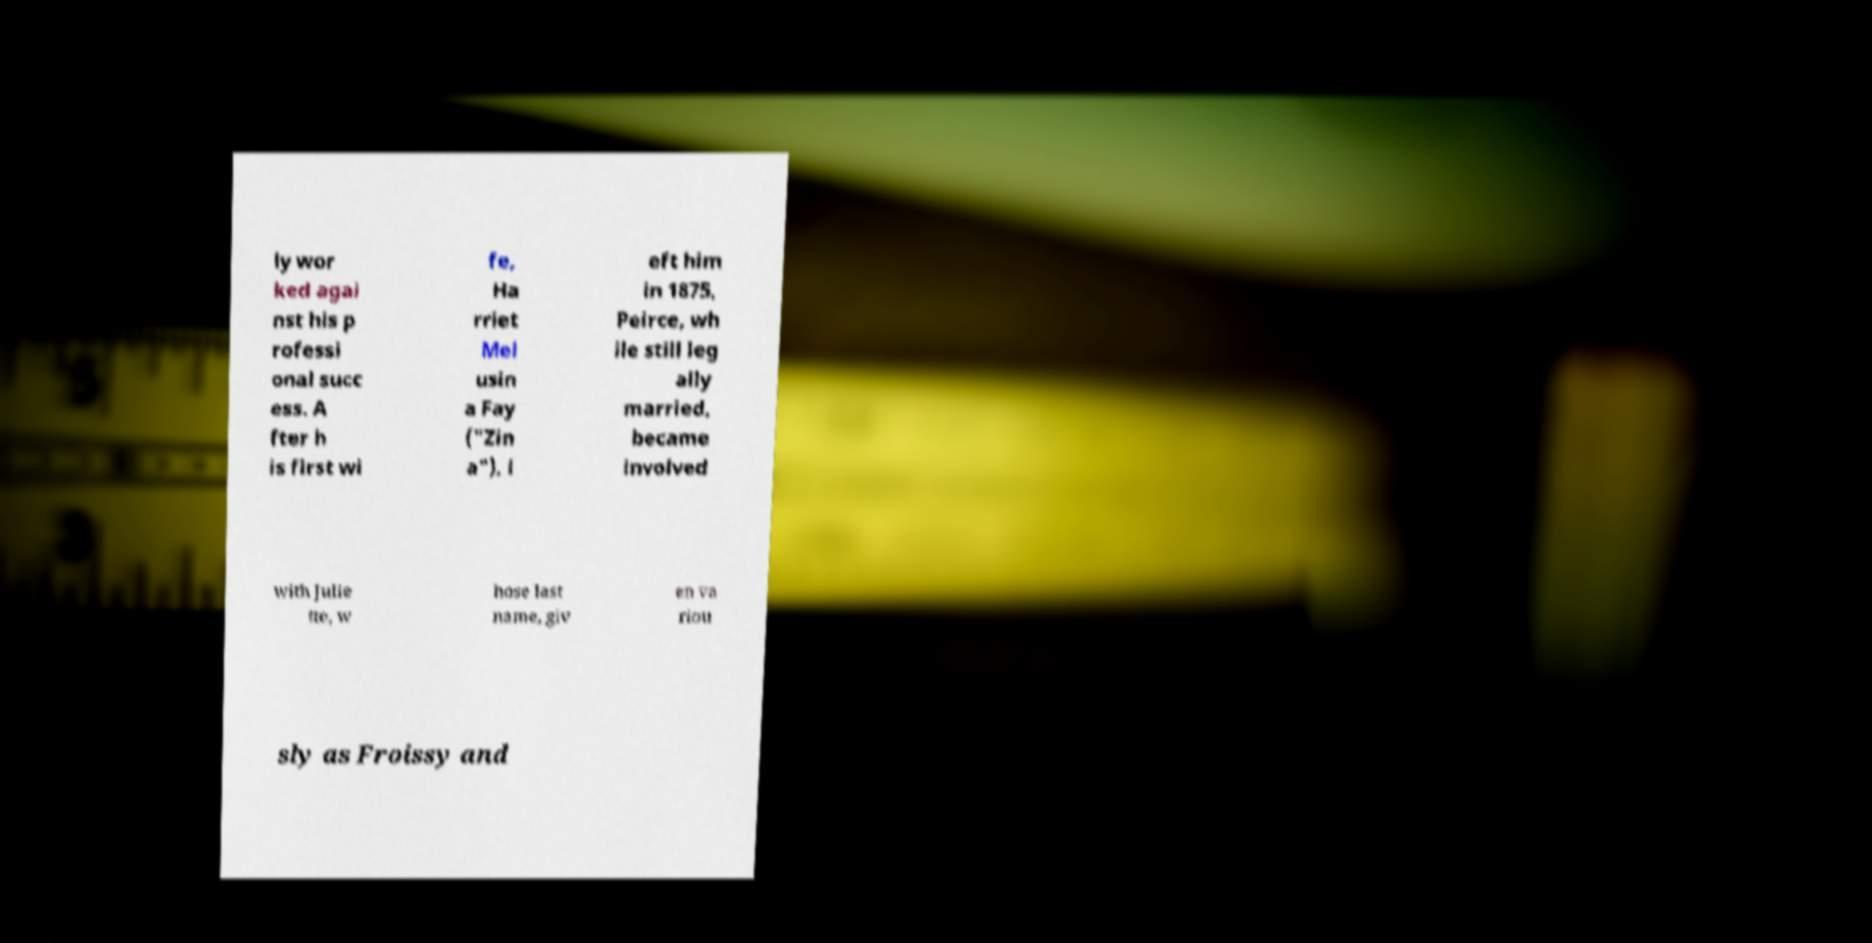What messages or text are displayed in this image? I need them in a readable, typed format. ly wor ked agai nst his p rofessi onal succ ess. A fter h is first wi fe, Ha rriet Mel usin a Fay ("Zin a"), l eft him in 1875, Peirce, wh ile still leg ally married, became involved with Julie tte, w hose last name, giv en va riou sly as Froissy and 